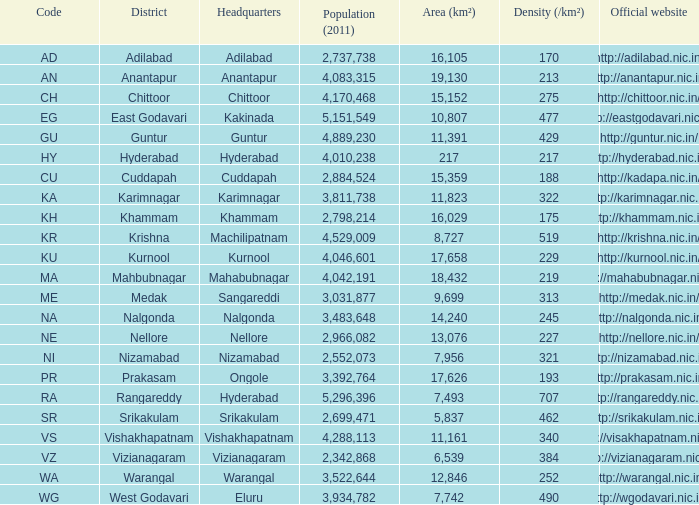What is the aggregate area of districts that have a density above 462 and possess websites with the url http://krishna.nic.in/? 8727.0. 